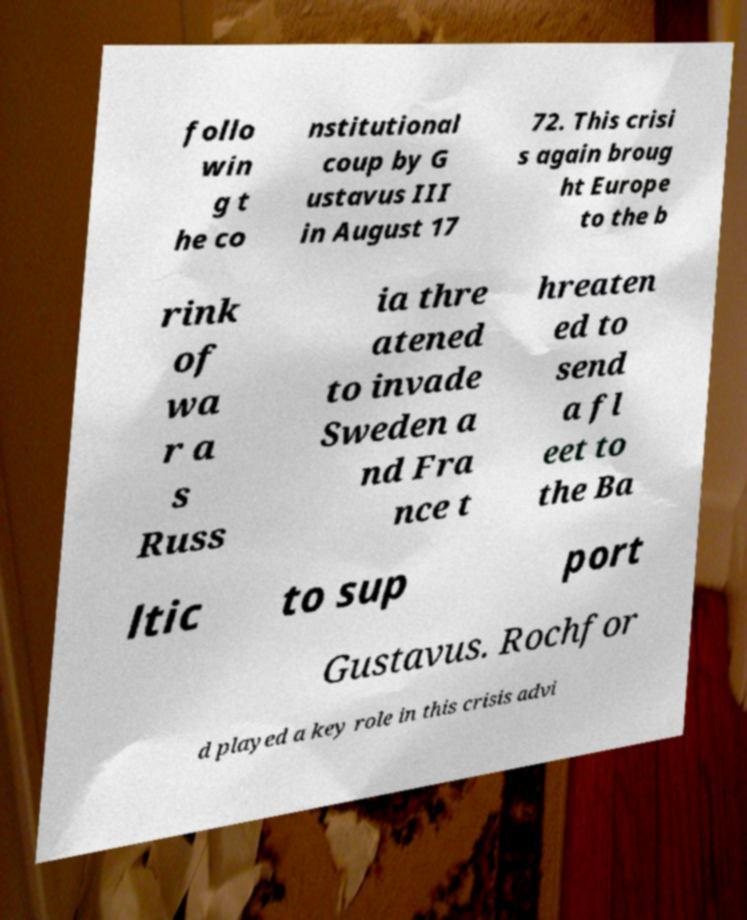Please read and relay the text visible in this image. What does it say? follo win g t he co nstitutional coup by G ustavus III in August 17 72. This crisi s again broug ht Europe to the b rink of wa r a s Russ ia thre atened to invade Sweden a nd Fra nce t hreaten ed to send a fl eet to the Ba ltic to sup port Gustavus. Rochfor d played a key role in this crisis advi 